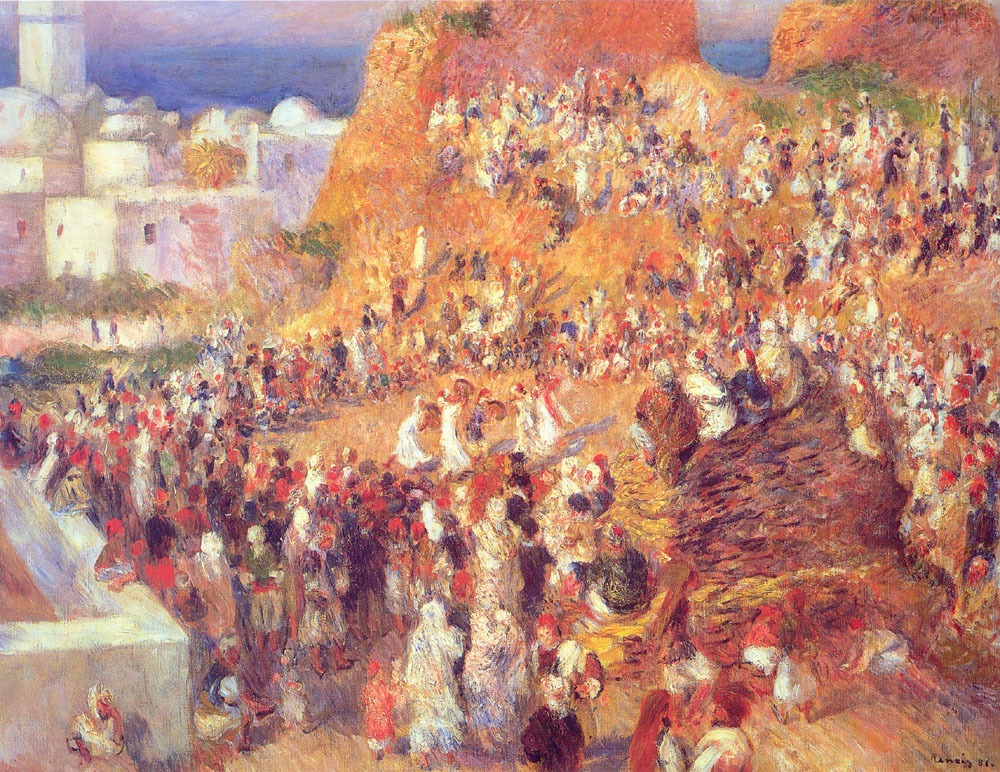What cultural or historical significance might this market scene hold? The market scene depicted in the painting could be of significant cultural and historical value. Markets have historically been central to Mediterranean life, acting as the heart of the community where people gather not just to trade goods, but also to socialize and share news. This painting could represent a typical day in a Mediterranean town, capturing the essence of daily life, traditions, and communal interactions. The attire of the people, the types of goods being traded, and the architectural style of the buildings can all provide insights into the historical period and cultural practices of the time. This scene might celebrate the richness of Mediterranean culture, showcasing the importance of community, commerce, and tradition in the region's history. 